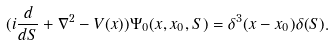Convert formula to latex. <formula><loc_0><loc_0><loc_500><loc_500>( i \frac { d } { d S } + \nabla ^ { 2 } - V ( x ) ) \Psi _ { 0 } ( x , x _ { 0 } , S ) = \delta ^ { 3 } ( x - x _ { 0 } ) \delta ( S ) .</formula> 